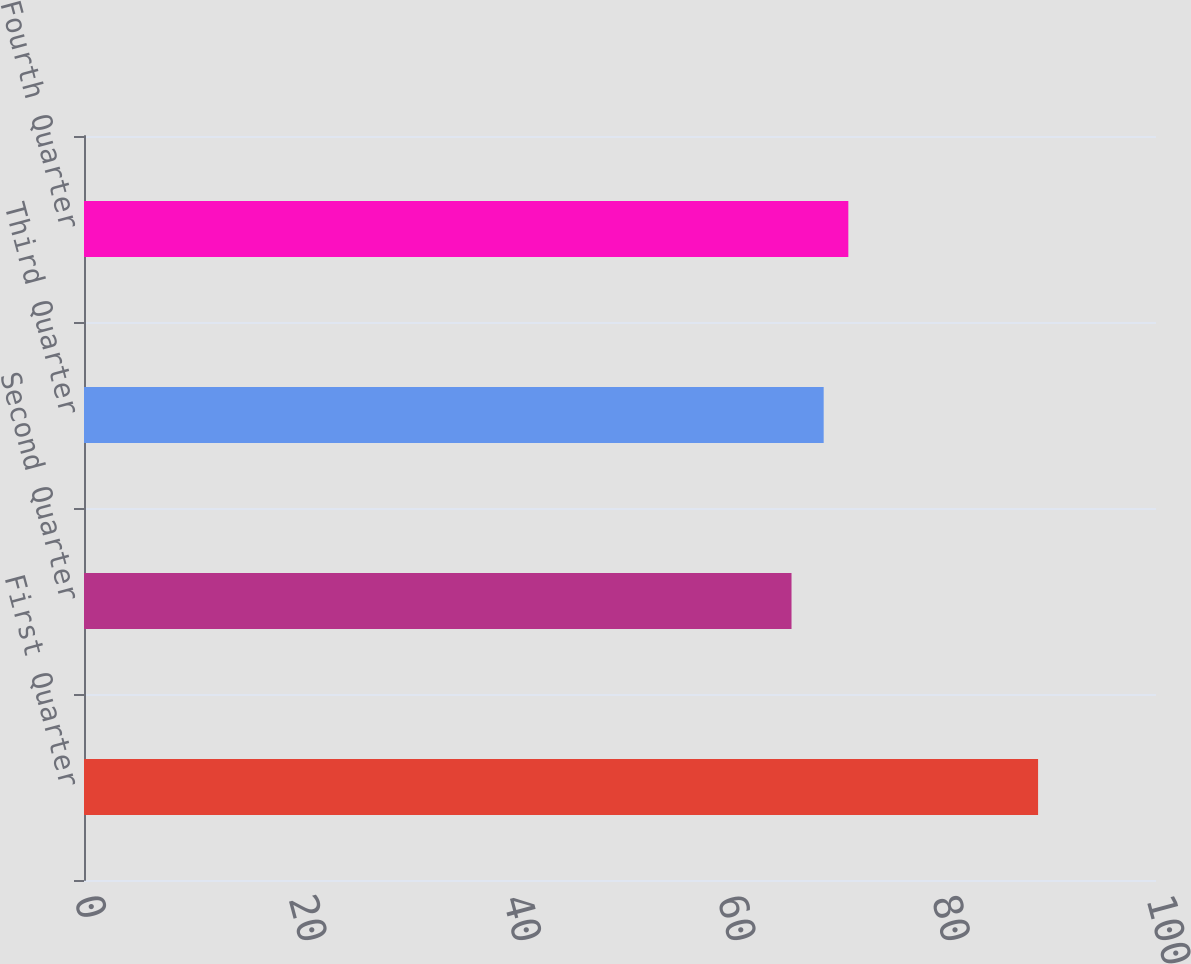Convert chart to OTSL. <chart><loc_0><loc_0><loc_500><loc_500><bar_chart><fcel>First Quarter<fcel>Second Quarter<fcel>Third Quarter<fcel>Fourth Quarter<nl><fcel>89<fcel>66<fcel>69<fcel>71.3<nl></chart> 